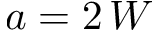<formula> <loc_0><loc_0><loc_500><loc_500>a = 2 \, W</formula> 